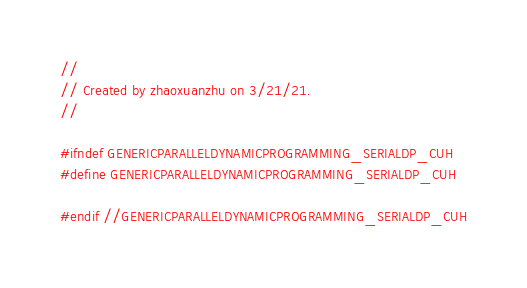<code> <loc_0><loc_0><loc_500><loc_500><_Cuda_>//
// Created by zhaoxuanzhu on 3/21/21.
//

#ifndef GENERICPARALLELDYNAMICPROGRAMMING_SERIALDP_CUH
#define GENERICPARALLELDYNAMICPROGRAMMING_SERIALDP_CUH

#endif //GENERICPARALLELDYNAMICPROGRAMMING_SERIALDP_CUH
</code> 